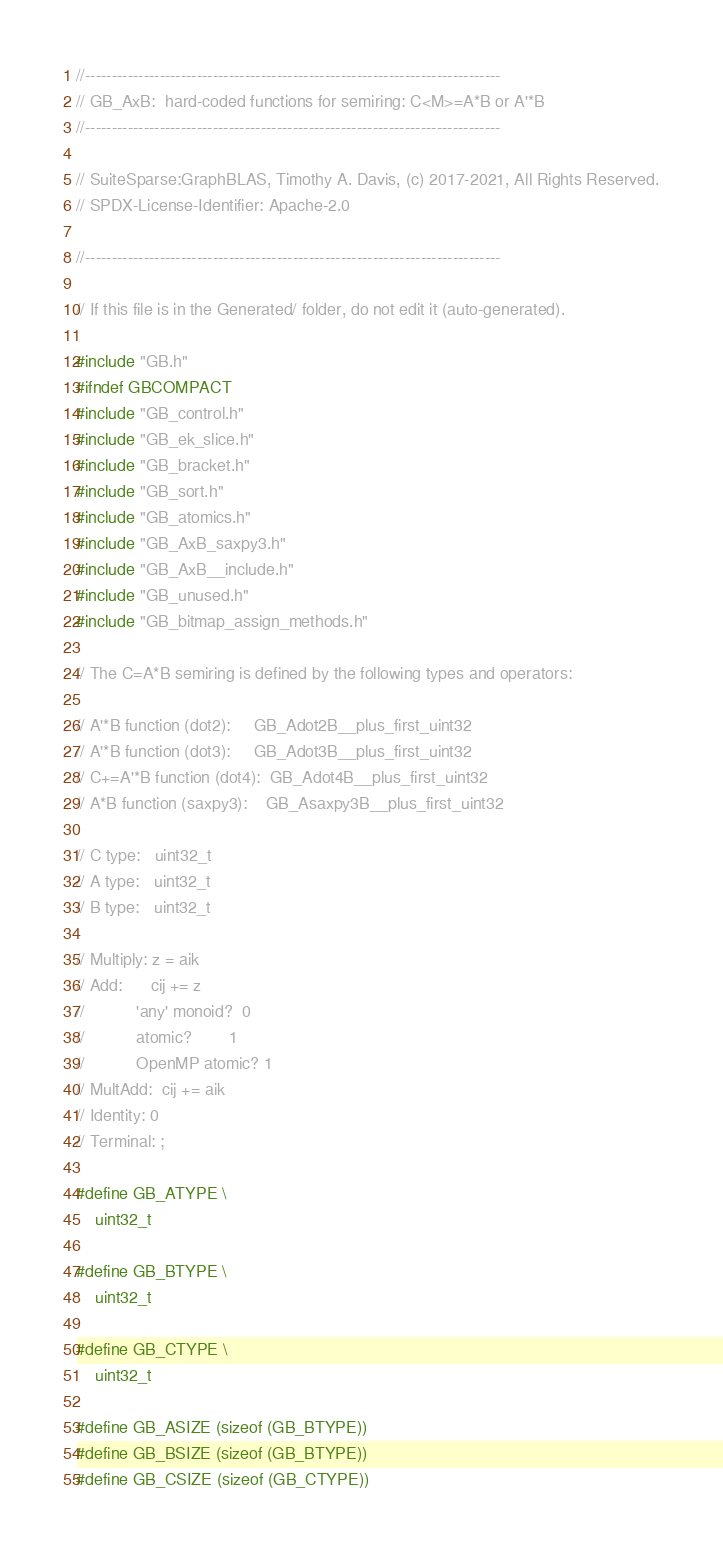<code> <loc_0><loc_0><loc_500><loc_500><_C_>//------------------------------------------------------------------------------
// GB_AxB:  hard-coded functions for semiring: C<M>=A*B or A'*B
//------------------------------------------------------------------------------

// SuiteSparse:GraphBLAS, Timothy A. Davis, (c) 2017-2021, All Rights Reserved.
// SPDX-License-Identifier: Apache-2.0

//------------------------------------------------------------------------------

// If this file is in the Generated/ folder, do not edit it (auto-generated).

#include "GB.h"
#ifndef GBCOMPACT
#include "GB_control.h"
#include "GB_ek_slice.h"
#include "GB_bracket.h"
#include "GB_sort.h"
#include "GB_atomics.h"
#include "GB_AxB_saxpy3.h"
#include "GB_AxB__include.h"
#include "GB_unused.h"
#include "GB_bitmap_assign_methods.h"

// The C=A*B semiring is defined by the following types and operators:

// A'*B function (dot2):     GB_Adot2B__plus_first_uint32
// A'*B function (dot3):     GB_Adot3B__plus_first_uint32
// C+=A'*B function (dot4):  GB_Adot4B__plus_first_uint32
// A*B function (saxpy3):    GB_Asaxpy3B__plus_first_uint32

// C type:   uint32_t
// A type:   uint32_t
// B type:   uint32_t

// Multiply: z = aik
// Add:      cij += z
//           'any' monoid?  0
//           atomic?        1
//           OpenMP atomic? 1
// MultAdd:  cij += aik
// Identity: 0
// Terminal: ;

#define GB_ATYPE \
    uint32_t

#define GB_BTYPE \
    uint32_t

#define GB_CTYPE \
    uint32_t

#define GB_ASIZE (sizeof (GB_BTYPE))
#define GB_BSIZE (sizeof (GB_BTYPE))
#define GB_CSIZE (sizeof (GB_CTYPE))
</code> 